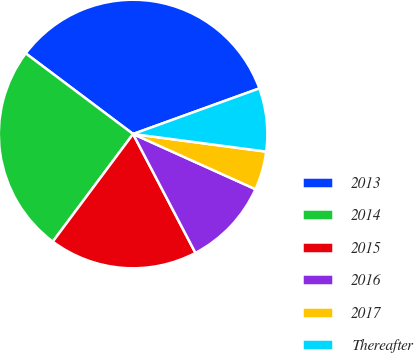<chart> <loc_0><loc_0><loc_500><loc_500><pie_chart><fcel>2013<fcel>2014<fcel>2015<fcel>2016<fcel>2017<fcel>Thereafter<nl><fcel>34.23%<fcel>25.05%<fcel>17.89%<fcel>10.57%<fcel>4.65%<fcel>7.61%<nl></chart> 